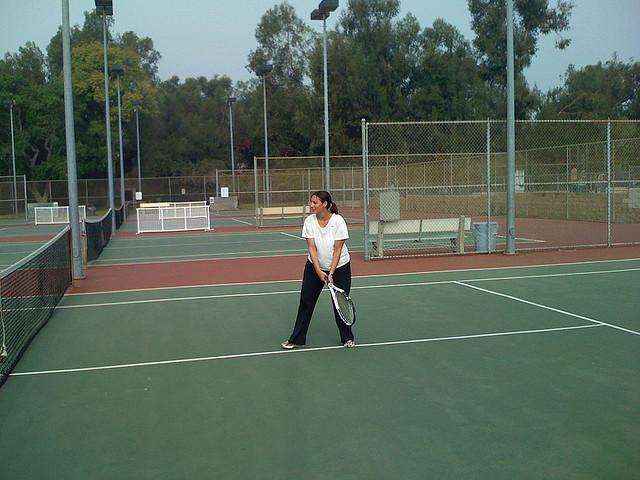How many rackets are there?
Answer briefly. 1. What sport is this woman playing?
Short answer required. Tennis. Is there anyone else playing on any of the other courts?
Give a very brief answer. No. What is the color of the woman top?
Keep it brief. White. 